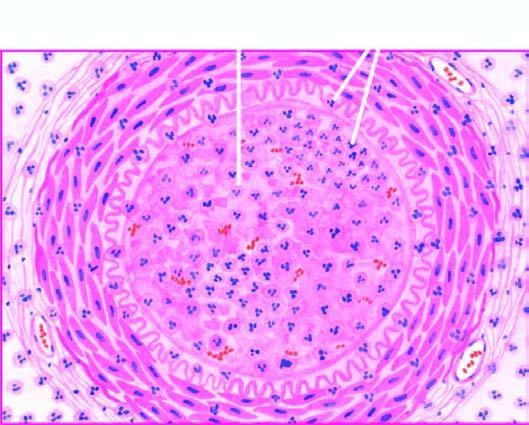what is there?
Answer the question using a single word or phrase. Acute panarteritis 